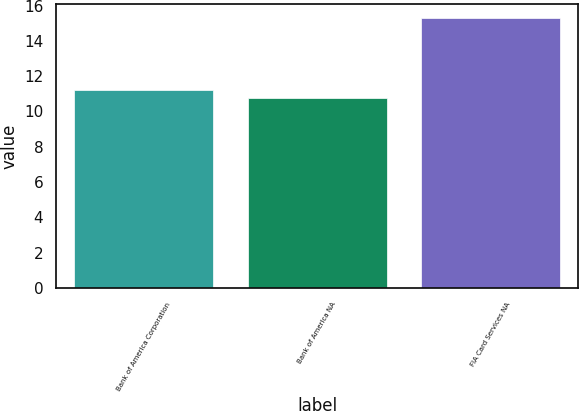Convert chart to OTSL. <chart><loc_0><loc_0><loc_500><loc_500><bar_chart><fcel>Bank of America Corporation<fcel>Bank of America NA<fcel>FIA Card Services NA<nl><fcel>11.24<fcel>10.78<fcel>15.3<nl></chart> 